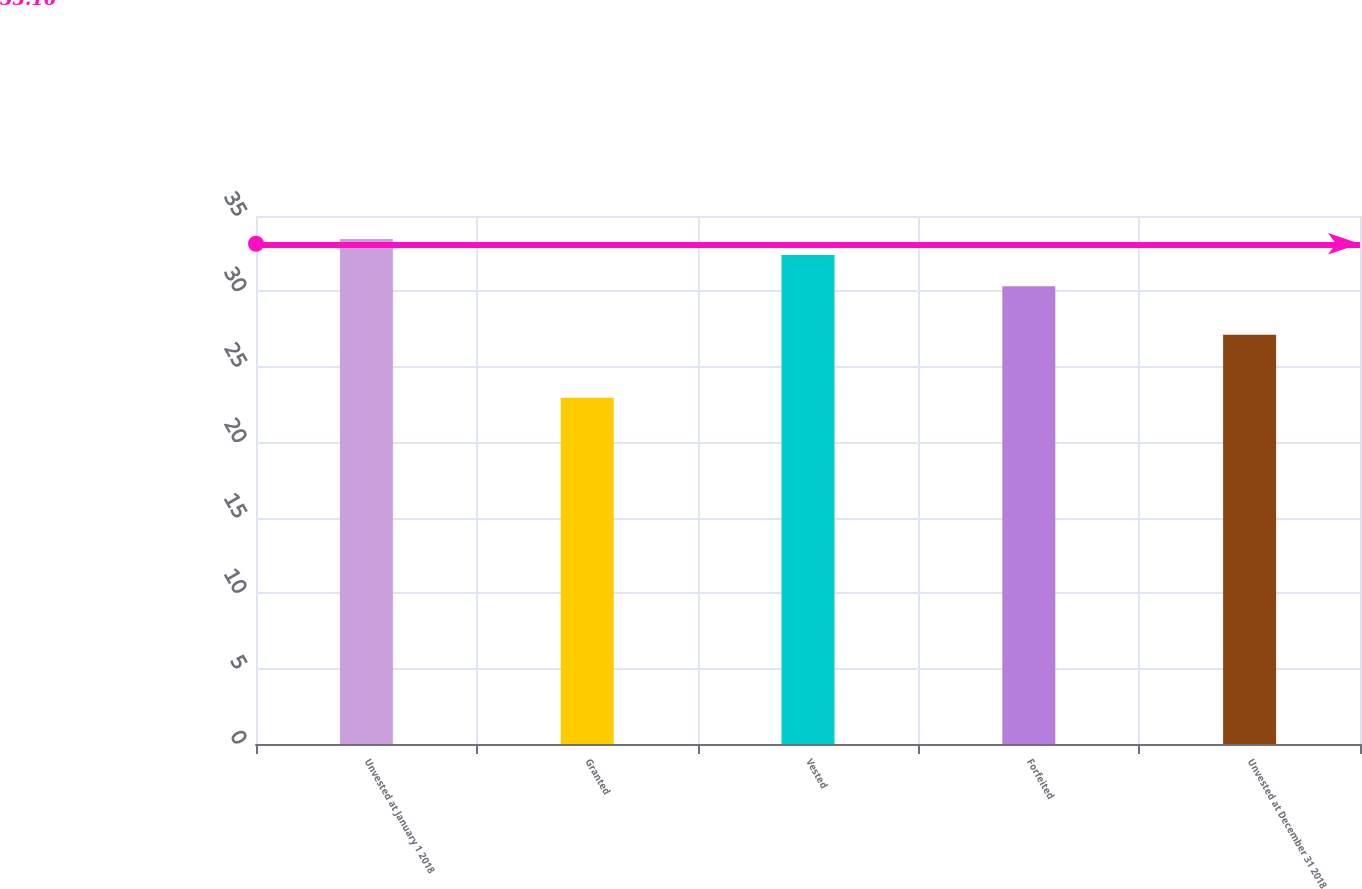Convert chart. <chart><loc_0><loc_0><loc_500><loc_500><bar_chart><fcel>Unvested at January 1 2018<fcel>Granted<fcel>Vested<fcel>Forfeited<fcel>Unvested at December 31 2018<nl><fcel>33.47<fcel>22.95<fcel>32.42<fcel>30.34<fcel>27.13<nl></chart> 